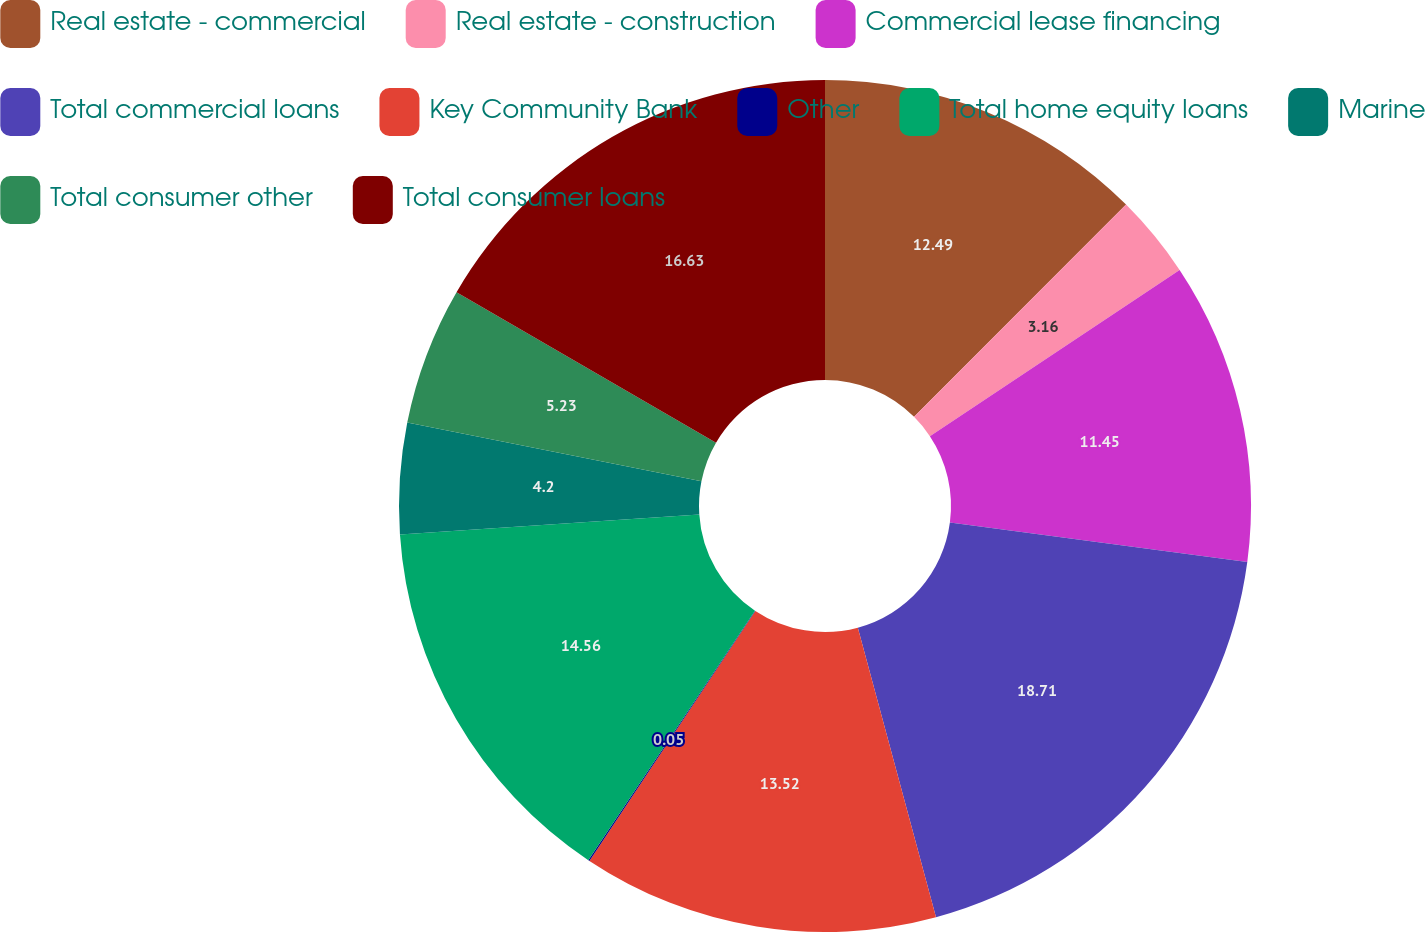Convert chart. <chart><loc_0><loc_0><loc_500><loc_500><pie_chart><fcel>Real estate - commercial<fcel>Real estate - construction<fcel>Commercial lease financing<fcel>Total commercial loans<fcel>Key Community Bank<fcel>Other<fcel>Total home equity loans<fcel>Marine<fcel>Total consumer other<fcel>Total consumer loans<nl><fcel>12.49%<fcel>3.16%<fcel>11.45%<fcel>18.7%<fcel>13.52%<fcel>0.05%<fcel>14.56%<fcel>4.2%<fcel>5.23%<fcel>16.63%<nl></chart> 